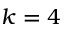Convert formula to latex. <formula><loc_0><loc_0><loc_500><loc_500>k = 4</formula> 